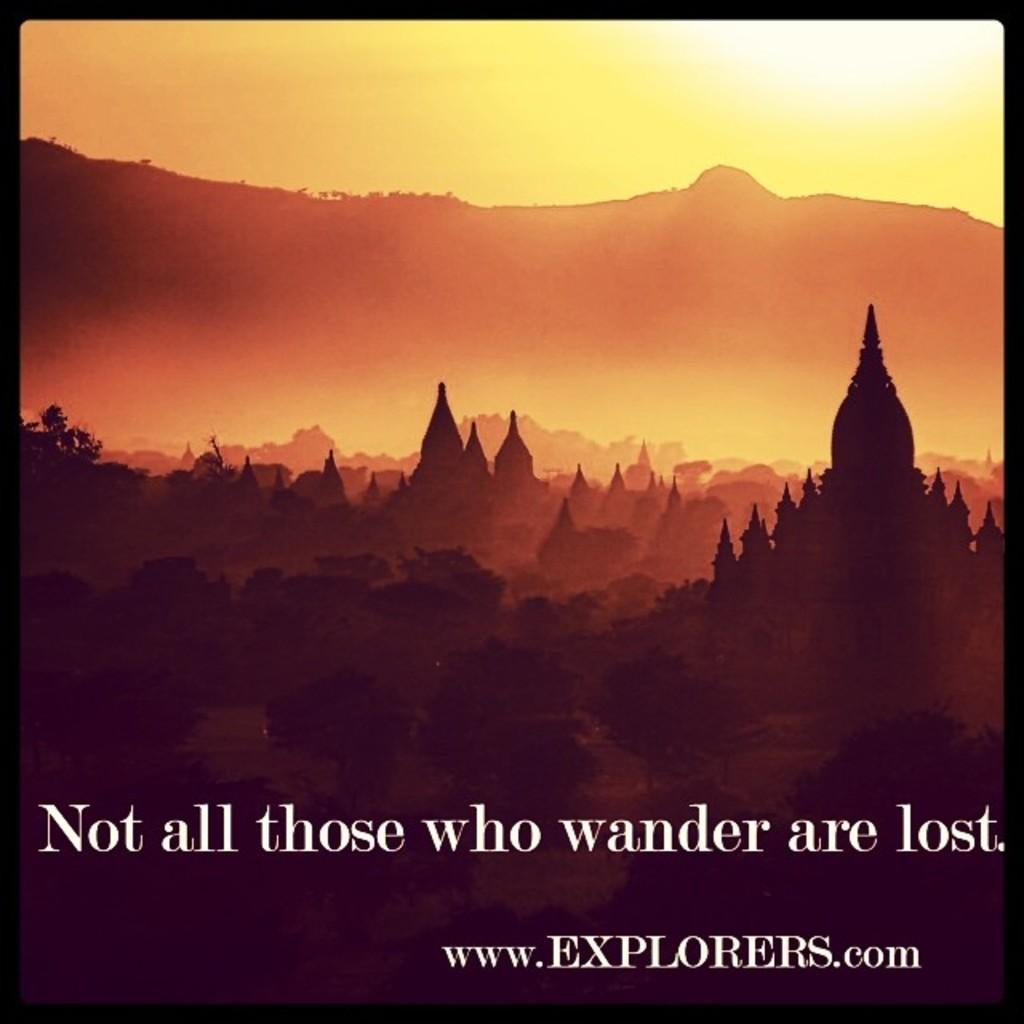What can be found at the bottom of the image? There is text at the bottom of the image. What is the main subject of the image? There is an architecture in the image. What type of vegetation is on the left side of the image? There are plants on the left side of the image. Can you tell me how many pigs are depicted in the image? There are no pigs present in the image. What type of butter is used in the architecture shown in the image? There is no butter mentioned or depicted in the image. 